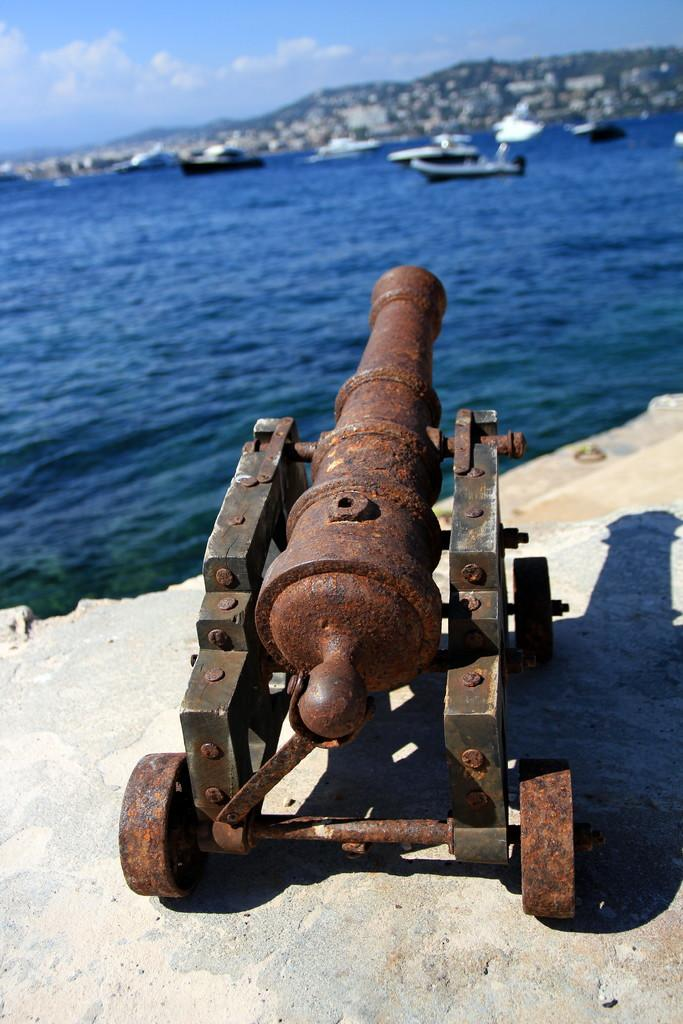What object is located on the ground in the image? There is a cannon on the ground in the image. What natural element can be seen in the image? Water is visible in the image. What type of vehicles are present in the image? Boats are present in the image. What geographical feature is visible in the image? There are mountains in the image. What part of the sky is visible in the image? The sky is visible in the image. What atmospheric feature can be seen in the sky? Clouds are present in the sky. What time of day is it in the image, and who is the uncle of the person holding the pocket? The time of day is not mentioned in the image, and there is no reference to an uncle or a pocket. 